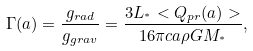Convert formula to latex. <formula><loc_0><loc_0><loc_500><loc_500>\Gamma ( a ) = \frac { g _ { r a d } } { g _ { g r a v } } = \frac { 3 L _ { ^ { * } } < Q _ { p r } ( a ) > } { 1 6 \pi c a \rho G M _ { ^ { * } } } ,</formula> 